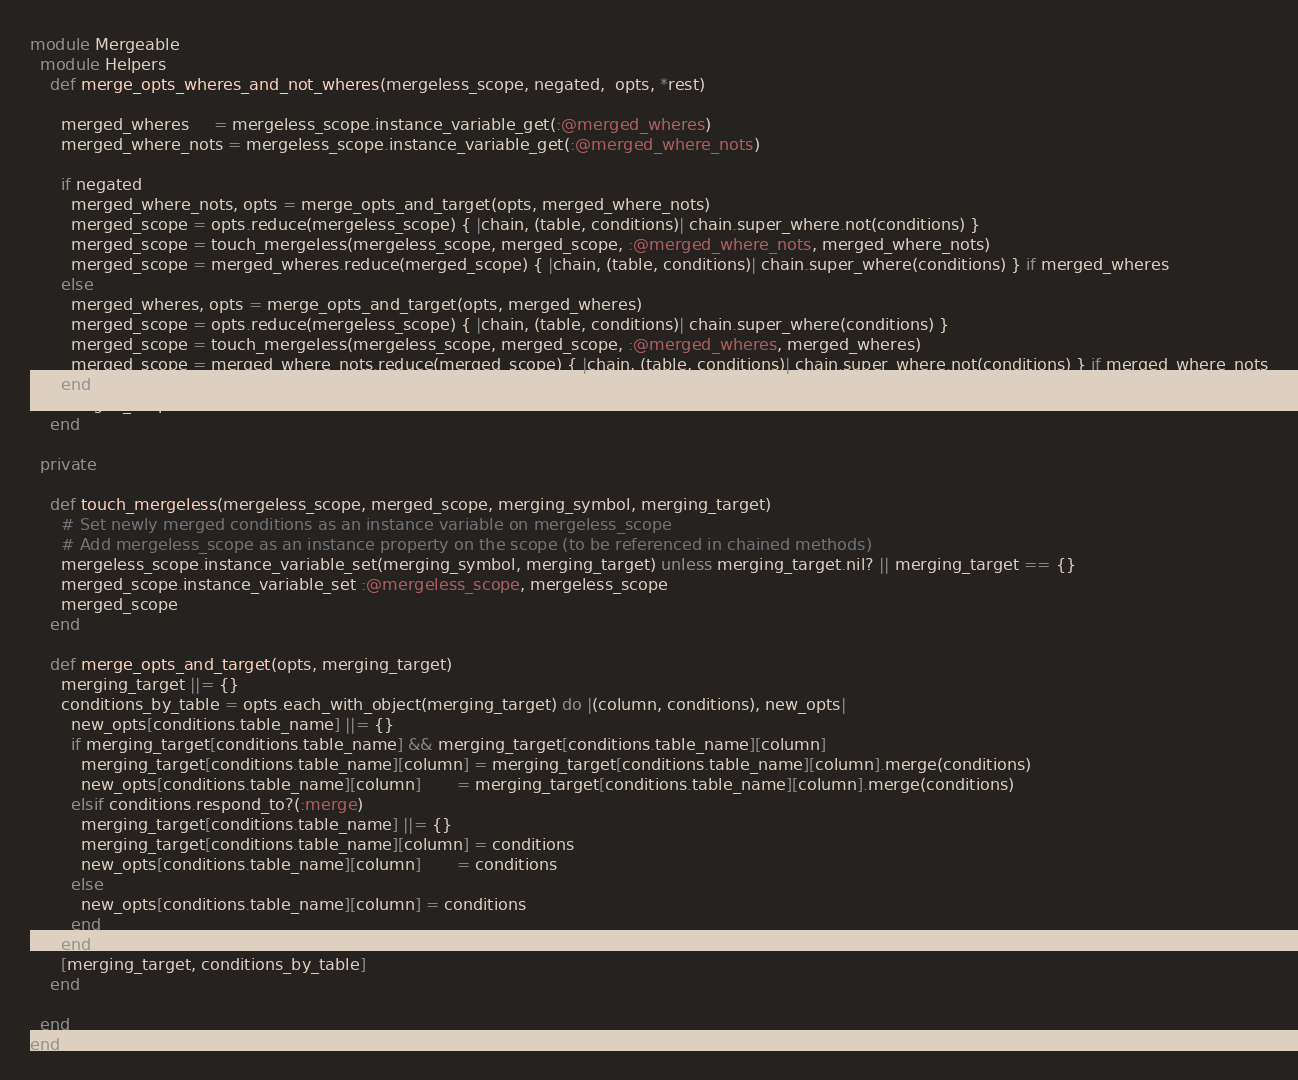<code> <loc_0><loc_0><loc_500><loc_500><_Ruby_>module Mergeable
  module Helpers
    def merge_opts_wheres_and_not_wheres(mergeless_scope, negated,  opts, *rest)

      merged_wheres     = mergeless_scope.instance_variable_get(:@merged_wheres)
      merged_where_nots = mergeless_scope.instance_variable_get(:@merged_where_nots)

      if negated
        merged_where_nots, opts = merge_opts_and_target(opts, merged_where_nots)
        merged_scope = opts.reduce(mergeless_scope) { |chain, (table, conditions)| chain.super_where.not(conditions) }
        merged_scope = touch_mergeless(mergeless_scope, merged_scope, :@merged_where_nots, merged_where_nots)
        merged_scope = merged_wheres.reduce(merged_scope) { |chain, (table, conditions)| chain.super_where(conditions) } if merged_wheres
      else
        merged_wheres, opts = merge_opts_and_target(opts, merged_wheres)
        merged_scope = opts.reduce(mergeless_scope) { |chain, (table, conditions)| chain.super_where(conditions) }
        merged_scope = touch_mergeless(mergeless_scope, merged_scope, :@merged_wheres, merged_wheres)
        merged_scope = merged_where_nots.reduce(merged_scope) { |chain, (table, conditions)| chain.super_where.not(conditions) } if merged_where_nots
      end
      merged_scope
    end

  private

    def touch_mergeless(mergeless_scope, merged_scope, merging_symbol, merging_target)
      # Set newly merged conditions as an instance variable on mergeless_scope
      # Add mergeless_scope as an instance property on the scope (to be referenced in chained methods)
      mergeless_scope.instance_variable_set(merging_symbol, merging_target) unless merging_target.nil? || merging_target == {}
      merged_scope.instance_variable_set :@mergeless_scope, mergeless_scope
      merged_scope
    end

    def merge_opts_and_target(opts, merging_target)
      merging_target ||= {}
      conditions_by_table = opts.each_with_object(merging_target) do |(column, conditions), new_opts|
        new_opts[conditions.table_name] ||= {}
        if merging_target[conditions.table_name] && merging_target[conditions.table_name][column]
          merging_target[conditions.table_name][column] = merging_target[conditions.table_name][column].merge(conditions)
          new_opts[conditions.table_name][column]       = merging_target[conditions.table_name][column].merge(conditions)
        elsif conditions.respond_to?(:merge)
          merging_target[conditions.table_name] ||= {}
          merging_target[conditions.table_name][column] = conditions
          new_opts[conditions.table_name][column]       = conditions
        else
          new_opts[conditions.table_name][column] = conditions
        end
      end
      [merging_target, conditions_by_table]
    end

  end
end
</code> 